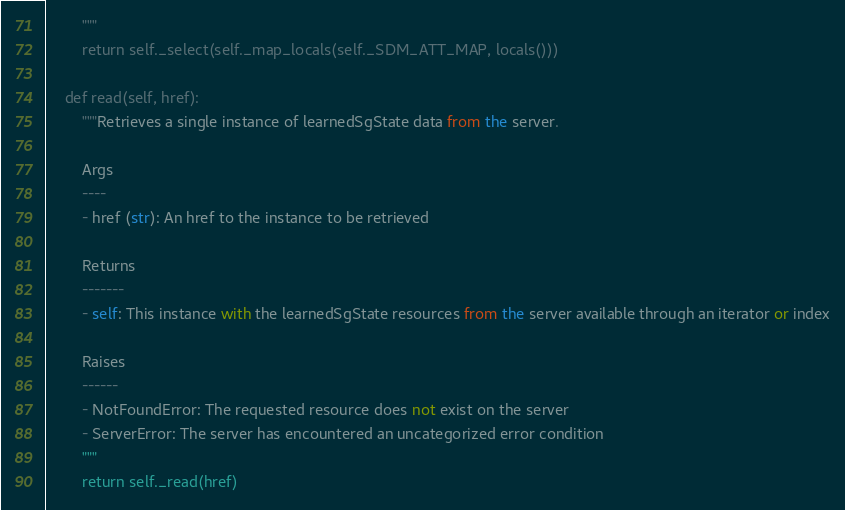Convert code to text. <code><loc_0><loc_0><loc_500><loc_500><_Python_>        """
        return self._select(self._map_locals(self._SDM_ATT_MAP, locals()))

    def read(self, href):
        """Retrieves a single instance of learnedSgState data from the server.

        Args
        ----
        - href (str): An href to the instance to be retrieved

        Returns
        -------
        - self: This instance with the learnedSgState resources from the server available through an iterator or index

        Raises
        ------
        - NotFoundError: The requested resource does not exist on the server
        - ServerError: The server has encountered an uncategorized error condition
        """
        return self._read(href)
</code> 